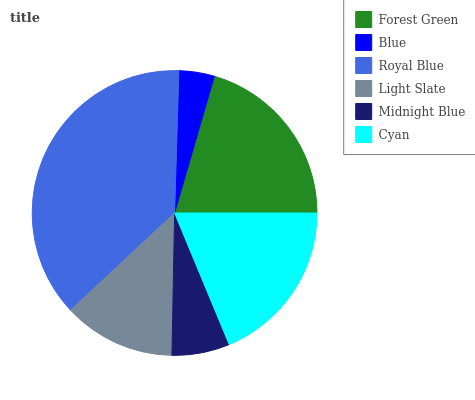Is Blue the minimum?
Answer yes or no. Yes. Is Royal Blue the maximum?
Answer yes or no. Yes. Is Royal Blue the minimum?
Answer yes or no. No. Is Blue the maximum?
Answer yes or no. No. Is Royal Blue greater than Blue?
Answer yes or no. Yes. Is Blue less than Royal Blue?
Answer yes or no. Yes. Is Blue greater than Royal Blue?
Answer yes or no. No. Is Royal Blue less than Blue?
Answer yes or no. No. Is Cyan the high median?
Answer yes or no. Yes. Is Light Slate the low median?
Answer yes or no. Yes. Is Blue the high median?
Answer yes or no. No. Is Midnight Blue the low median?
Answer yes or no. No. 